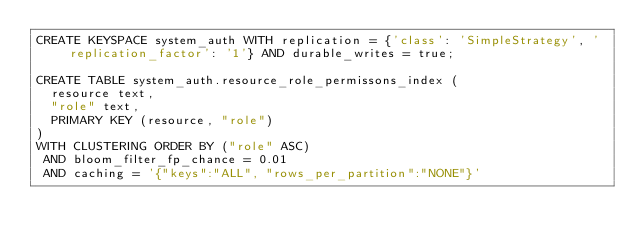Convert code to text. <code><loc_0><loc_0><loc_500><loc_500><_SQL_>CREATE KEYSPACE system_auth WITH replication = {'class': 'SimpleStrategy', 'replication_factor': '1'} AND durable_writes = true;

CREATE TABLE system_auth.resource_role_permissons_index (
  resource text,
  "role" text,
  PRIMARY KEY (resource, "role")
)
WITH CLUSTERING ORDER BY ("role" ASC)
 AND bloom_filter_fp_chance = 0.01
 AND caching = '{"keys":"ALL", "rows_per_partition":"NONE"}'</code> 